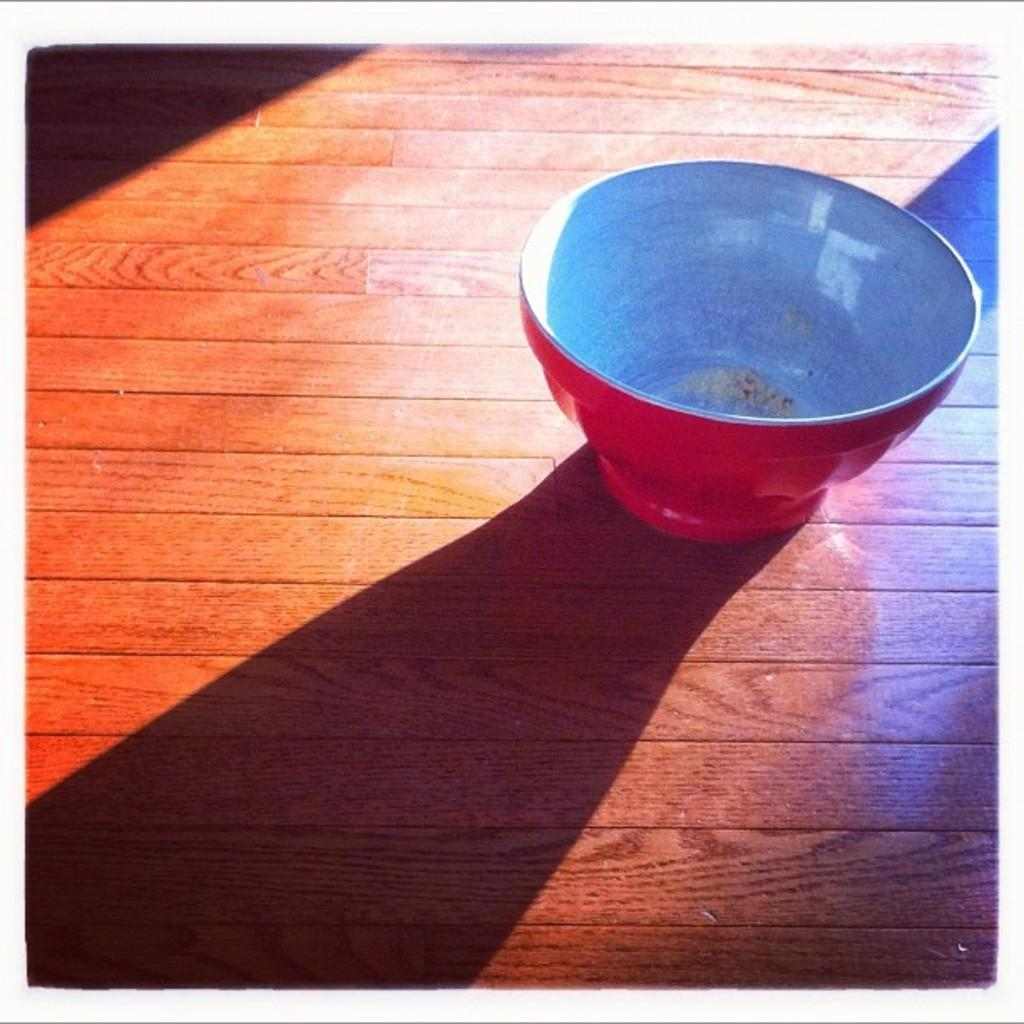What object is in the image? There is a red ball in the image. Where is the red ball placed? The ball is placed on a wooden table. Can you describe the wooden table? The wooden table is brown in color. What else can be observed in the image? There is a shadow visible in the image. In which direction are the children walking in the image? There are no children present in the image, so it is not possible to determine the direction in which they might be walking. 